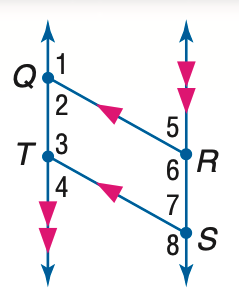Answer the mathemtical geometry problem and directly provide the correct option letter.
Question: In the figure, Q R \parallel T S, Q T \parallel R S, and m \angle 1 = 131. Find the measure of \angle 4.
Choices: A: 49 B: 59 C: 69 D: 131 A 